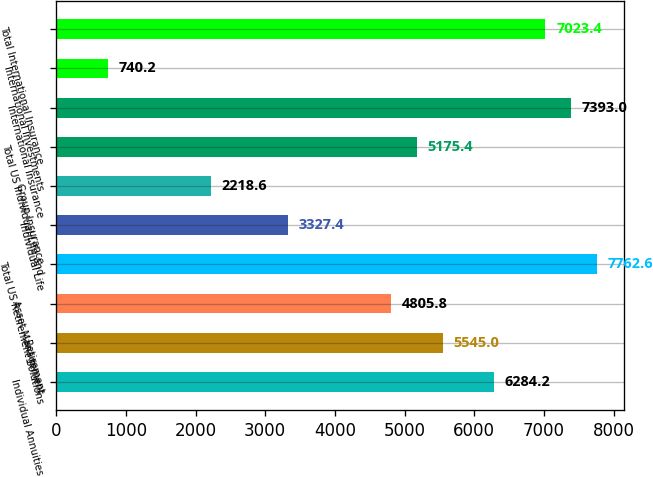<chart> <loc_0><loc_0><loc_500><loc_500><bar_chart><fcel>Individual Annuities<fcel>Retirement<fcel>Asset Management<fcel>Total US Retirement Solutions<fcel>Individual Life<fcel>Group Insurance<fcel>Total US Individual Life and<fcel>International Insurance<fcel>International Investments<fcel>Total International Insurance<nl><fcel>6284.2<fcel>5545<fcel>4805.8<fcel>7762.6<fcel>3327.4<fcel>2218.6<fcel>5175.4<fcel>7393<fcel>740.2<fcel>7023.4<nl></chart> 